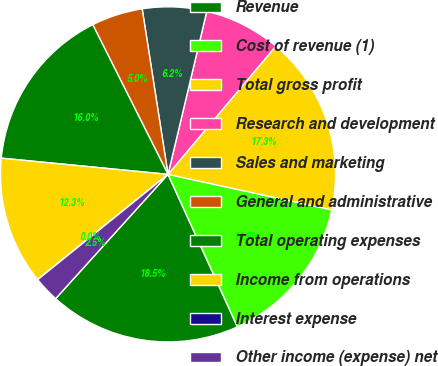<chart> <loc_0><loc_0><loc_500><loc_500><pie_chart><fcel>Revenue<fcel>Cost of revenue (1)<fcel>Total gross profit<fcel>Research and development<fcel>Sales and marketing<fcel>General and administrative<fcel>Total operating expenses<fcel>Income from operations<fcel>Interest expense<fcel>Other income (expense) net<nl><fcel>18.5%<fcel>14.8%<fcel>17.27%<fcel>7.41%<fcel>6.18%<fcel>4.95%<fcel>16.04%<fcel>12.34%<fcel>0.02%<fcel>2.48%<nl></chart> 